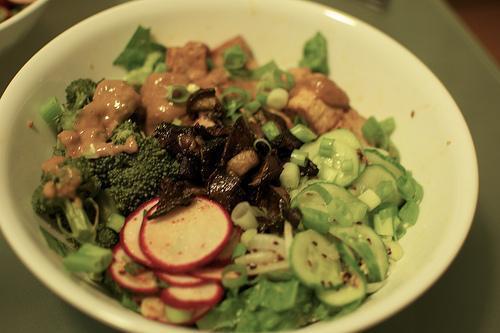How many bowls are there?
Give a very brief answer. 1. 